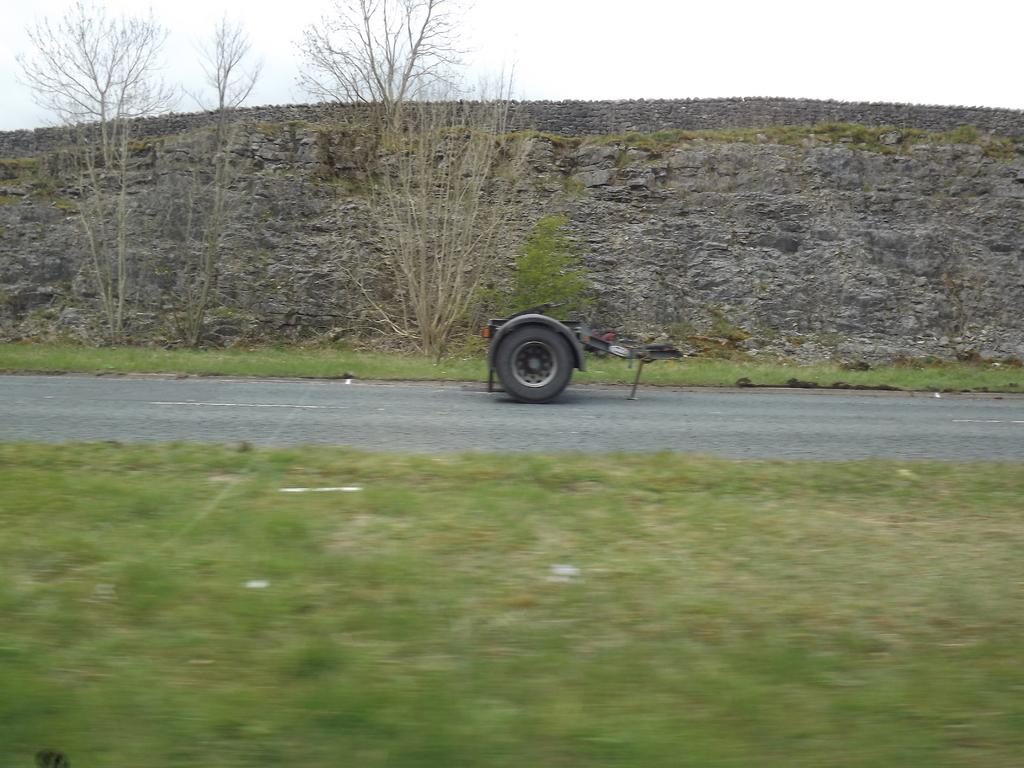What is the main subject of the image? The main subject of the image is a wheel of a truck. Where is the wheel located in the image? The wheel is on the road surface. What can be seen on either side of the road in the image? There is grass, trees, and rocks on either side of the road in the image. What type of request can be seen being made in the image? There is no request present in the image; it features a wheel of a truck on the road with grass, trees, and rocks on either side. 